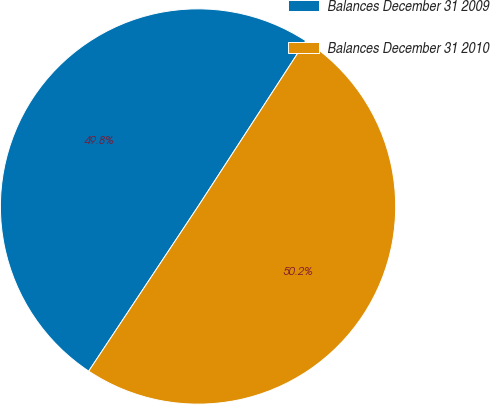<chart> <loc_0><loc_0><loc_500><loc_500><pie_chart><fcel>Balances December 31 2009<fcel>Balances December 31 2010<nl><fcel>49.85%<fcel>50.15%<nl></chart> 